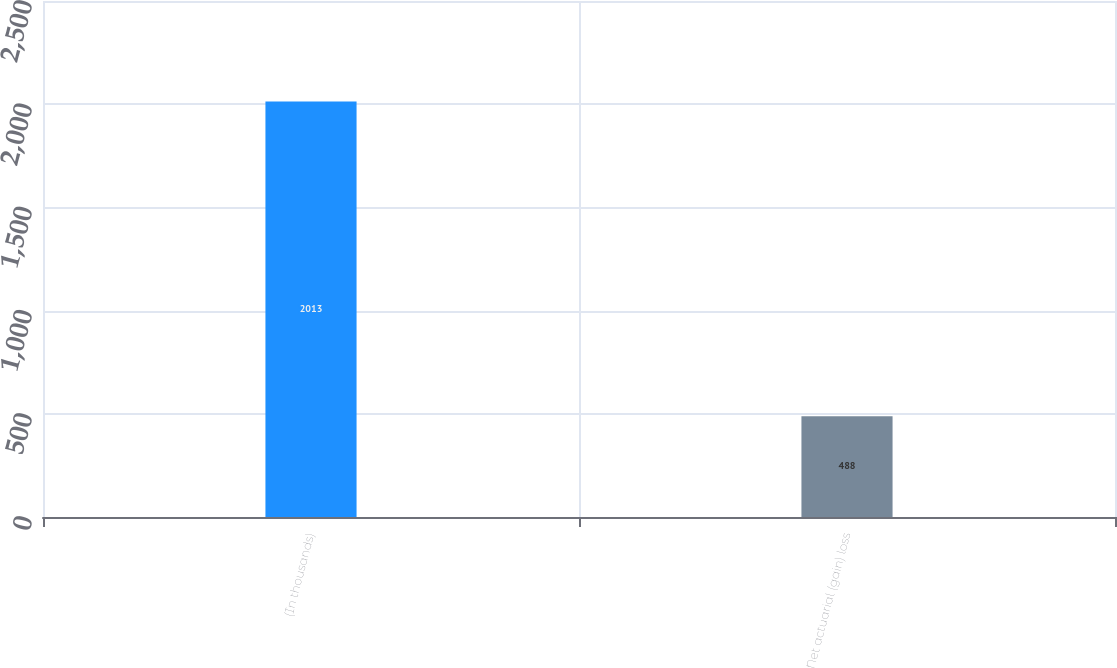Convert chart. <chart><loc_0><loc_0><loc_500><loc_500><bar_chart><fcel>(In thousands)<fcel>Net actuarial (gain) loss<nl><fcel>2013<fcel>488<nl></chart> 